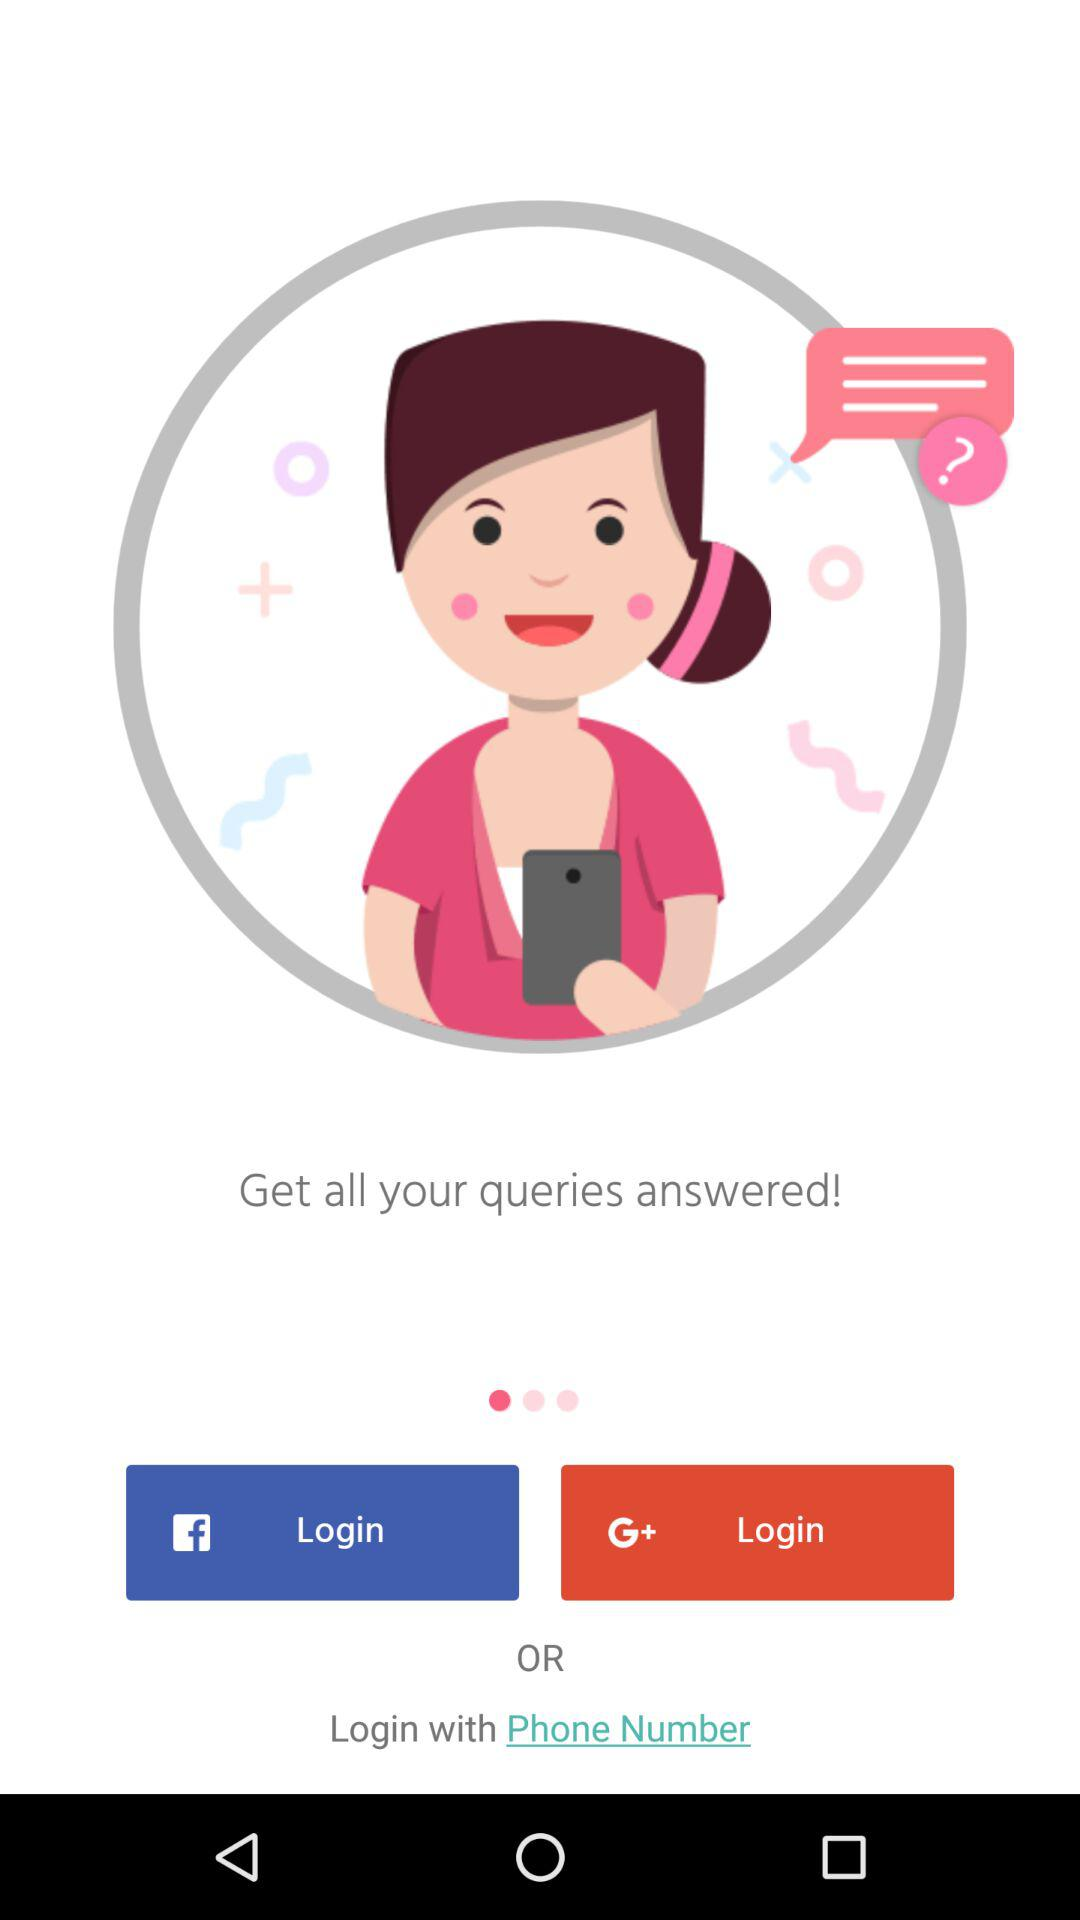How many more login options are there than social login options?
Answer the question using a single word or phrase. 1 